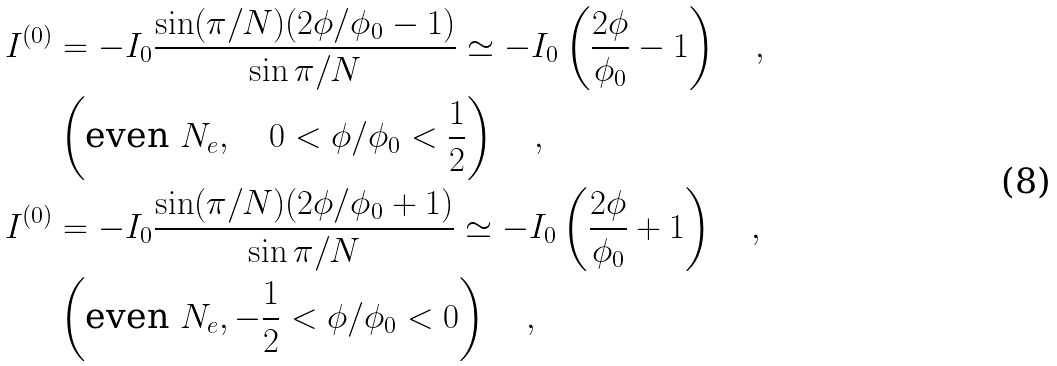Convert formula to latex. <formula><loc_0><loc_0><loc_500><loc_500>I ^ { ( 0 ) } & = - I _ { 0 } \frac { \sin ( \pi / N ) ( 2 \phi / \phi _ { 0 } - 1 ) } { \sin \pi / N } \simeq - I _ { 0 } \left ( \frac { 2 \phi } { \phi _ { 0 } } - 1 \right ) \quad , \\ & \left ( \text {even } N _ { e } , \quad 0 < \phi / \phi _ { 0 } < \frac { 1 } { 2 } \right ) \quad , \\ I ^ { ( 0 ) } & = - I _ { 0 } \frac { \sin ( \pi / N ) ( 2 \phi / \phi _ { 0 } + 1 ) } { \sin \pi / N } \simeq - I _ { 0 } \left ( \frac { 2 \phi } { \phi _ { 0 } } + 1 \right ) \quad , \\ & \left ( \text {even } N _ { e } , - \frac { 1 } { 2 } < \phi / \phi _ { 0 } < 0 \right ) \quad ,</formula> 